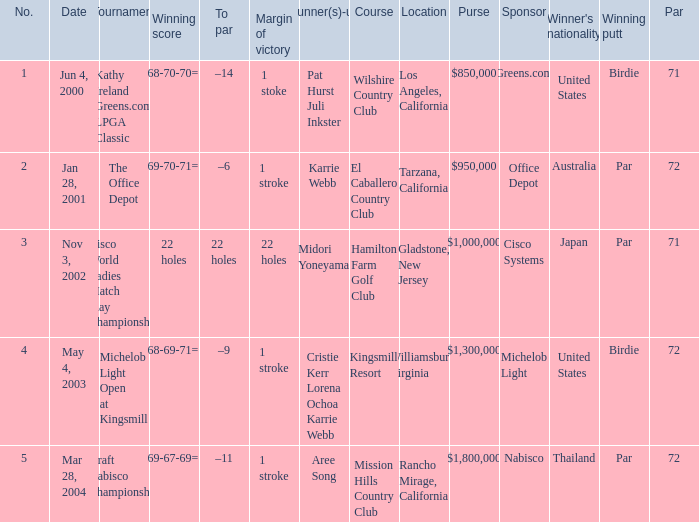What is the to par dated may 4, 2003? –9. 